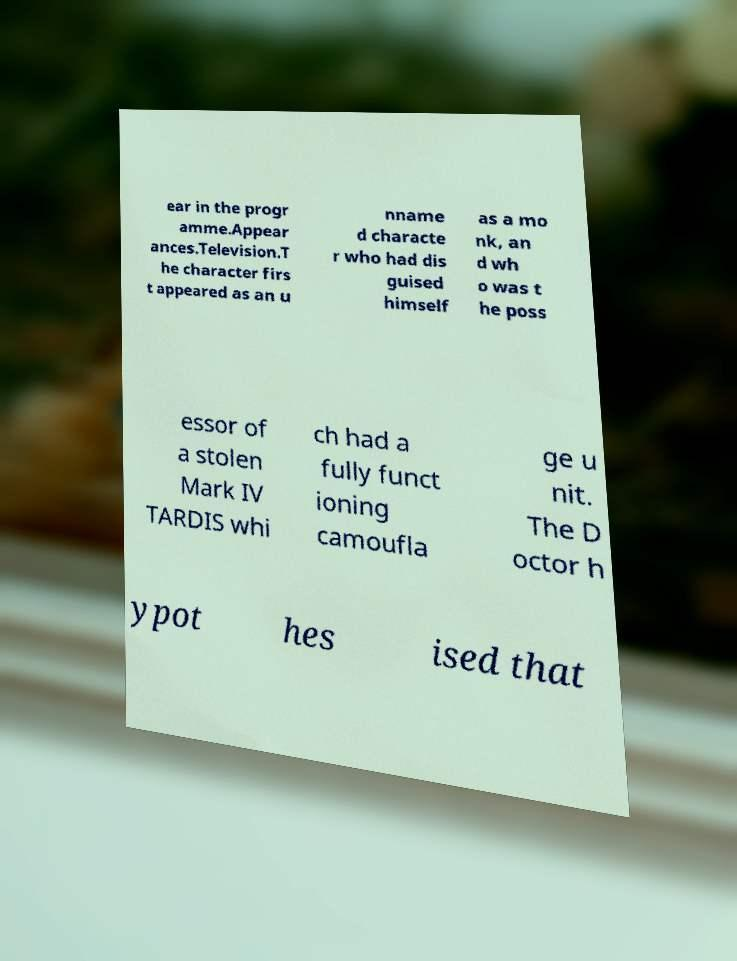Can you read and provide the text displayed in the image?This photo seems to have some interesting text. Can you extract and type it out for me? ear in the progr amme.Appear ances.Television.T he character firs t appeared as an u nname d characte r who had dis guised himself as a mo nk, an d wh o was t he poss essor of a stolen Mark IV TARDIS whi ch had a fully funct ioning camoufla ge u nit. The D octor h ypot hes ised that 